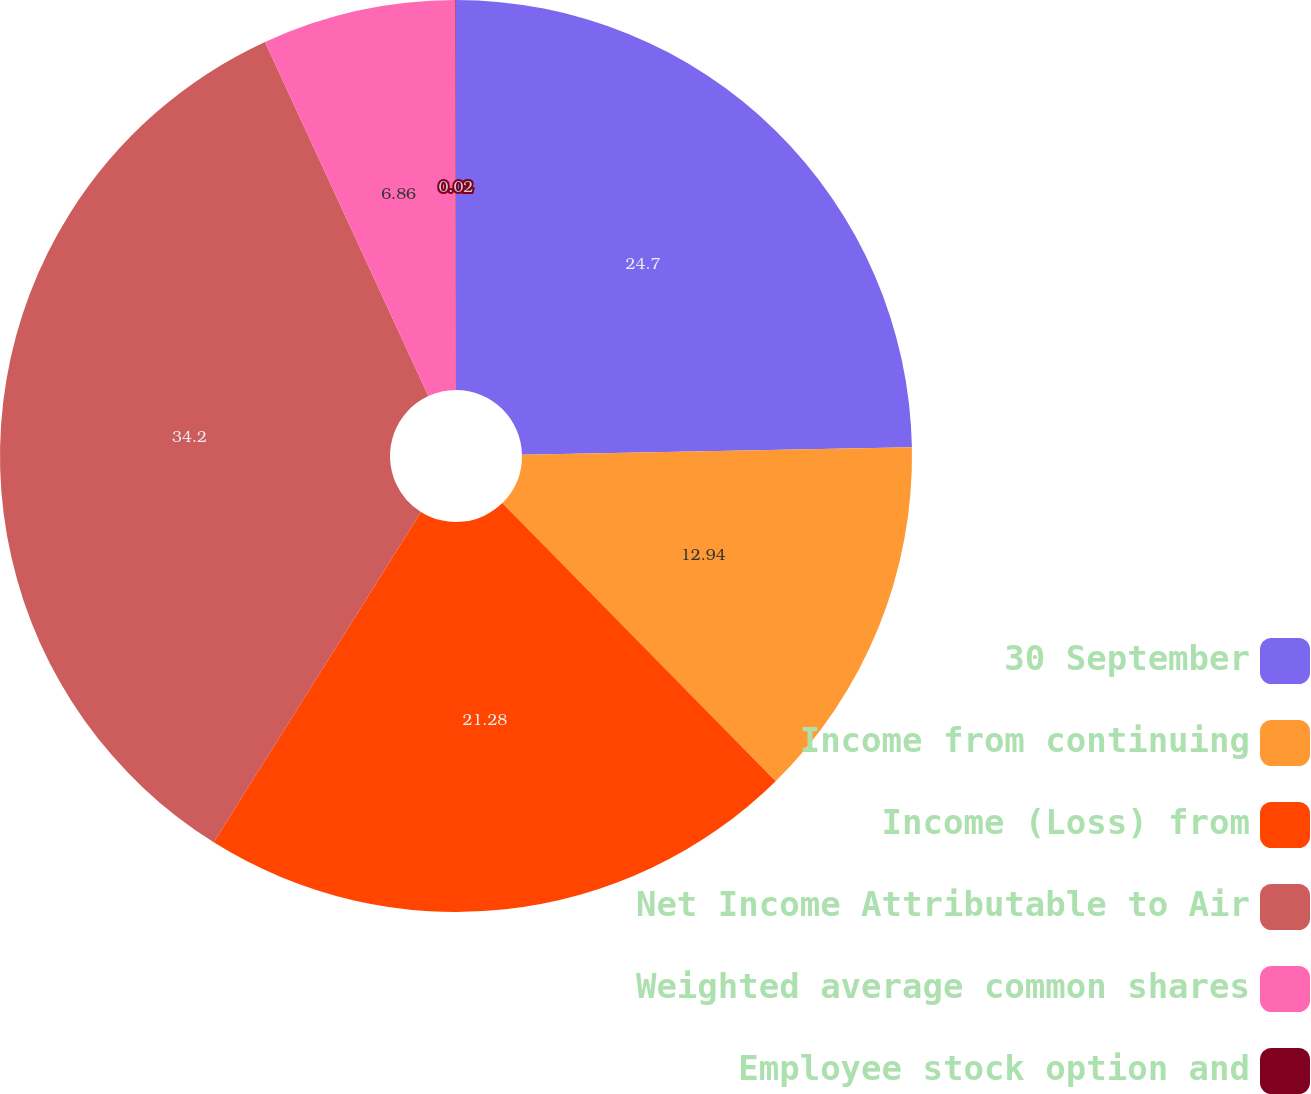<chart> <loc_0><loc_0><loc_500><loc_500><pie_chart><fcel>30 September<fcel>Income from continuing<fcel>Income (Loss) from<fcel>Net Income Attributable to Air<fcel>Weighted average common shares<fcel>Employee stock option and<nl><fcel>24.7%<fcel>12.94%<fcel>21.28%<fcel>34.21%<fcel>6.86%<fcel>0.02%<nl></chart> 